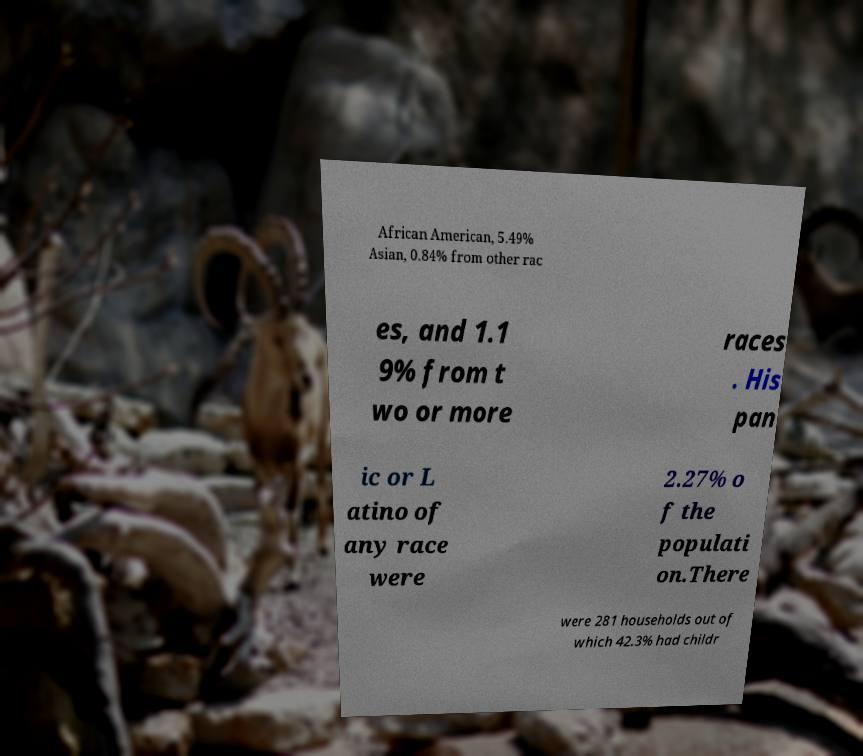Please identify and transcribe the text found in this image. African American, 5.49% Asian, 0.84% from other rac es, and 1.1 9% from t wo or more races . His pan ic or L atino of any race were 2.27% o f the populati on.There were 281 households out of which 42.3% had childr 